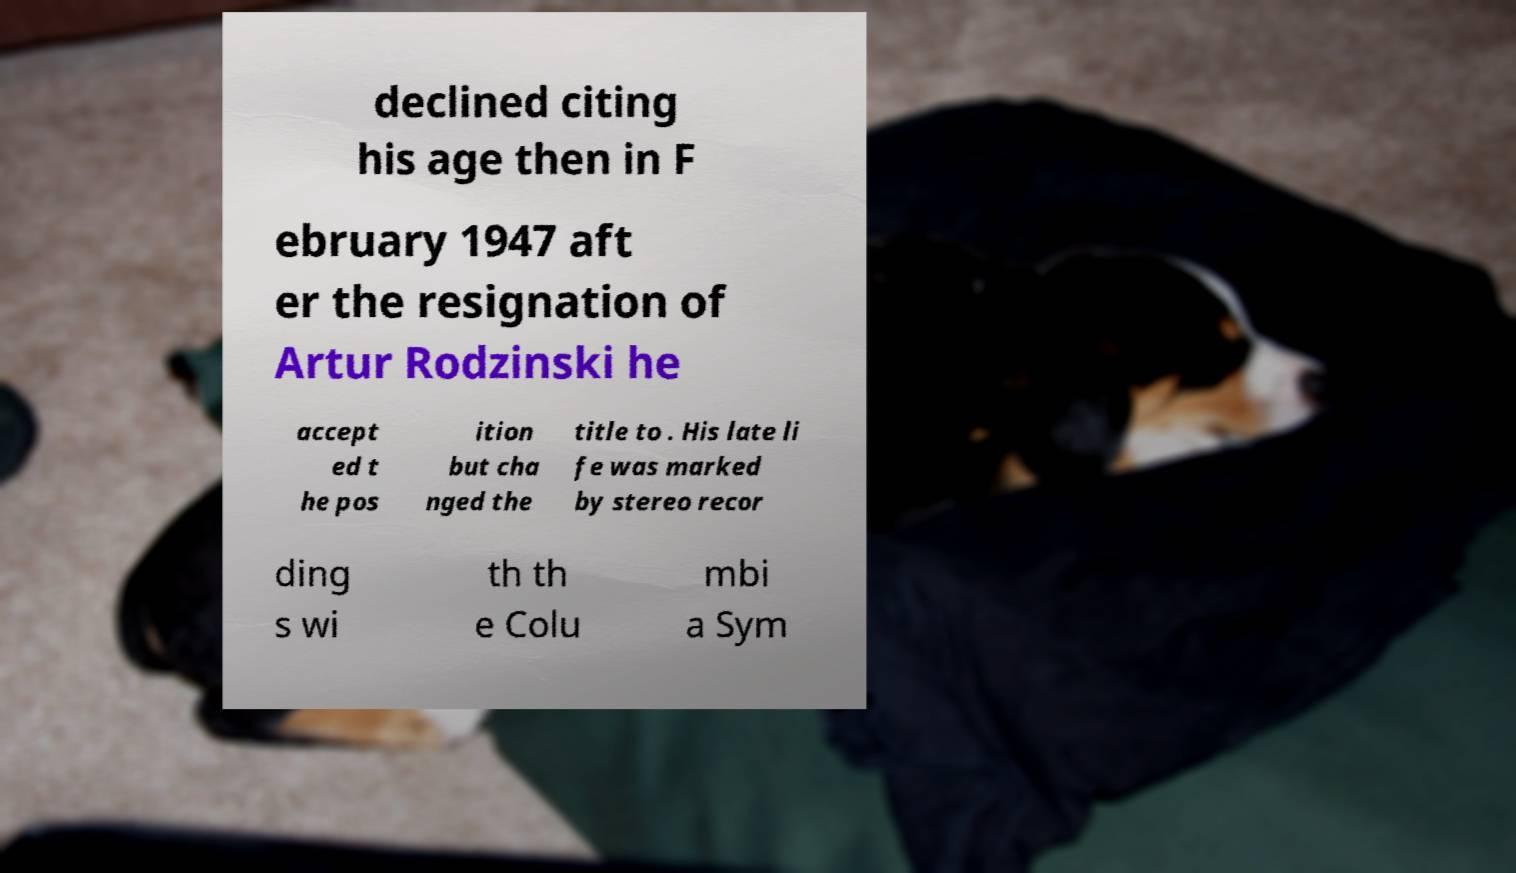Could you assist in decoding the text presented in this image and type it out clearly? declined citing his age then in F ebruary 1947 aft er the resignation of Artur Rodzinski he accept ed t he pos ition but cha nged the title to . His late li fe was marked by stereo recor ding s wi th th e Colu mbi a Sym 